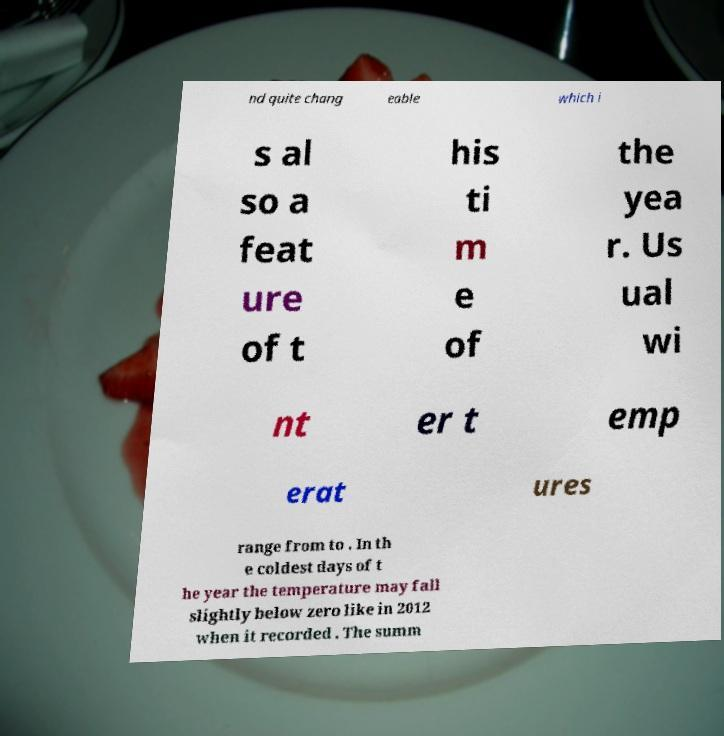Could you assist in decoding the text presented in this image and type it out clearly? nd quite chang eable which i s al so a feat ure of t his ti m e of the yea r. Us ual wi nt er t emp erat ures range from to . In th e coldest days of t he year the temperature may fall slightly below zero like in 2012 when it recorded . The summ 